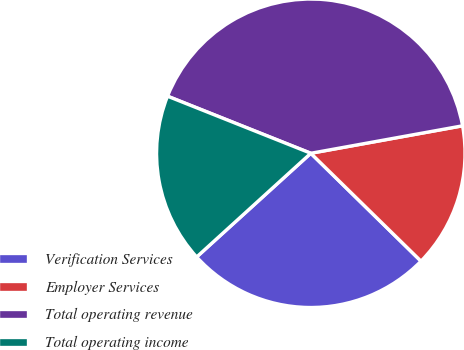Convert chart to OTSL. <chart><loc_0><loc_0><loc_500><loc_500><pie_chart><fcel>Verification Services<fcel>Employer Services<fcel>Total operating revenue<fcel>Total operating income<nl><fcel>25.93%<fcel>15.18%<fcel>41.11%<fcel>17.77%<nl></chart> 